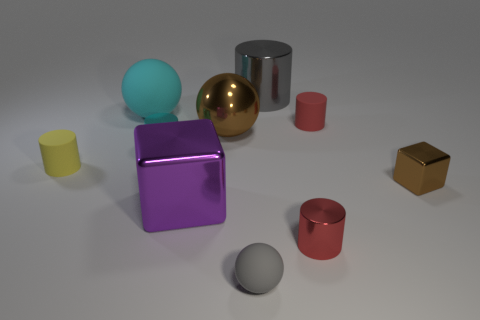Does the tiny red thing behind the big block have the same material as the big brown object?
Provide a succinct answer. No. What is the shape of the brown metal thing that is behind the brown metallic object on the right side of the shiny cylinder that is behind the large rubber thing?
Offer a very short reply. Sphere. Is there a yellow matte block that has the same size as the cyan rubber object?
Offer a terse response. No. How big is the purple metallic thing?
Provide a short and direct response. Large. What number of yellow objects have the same size as the cyan metal thing?
Your answer should be compact. 1. Is the number of big metal blocks that are behind the large purple cube less than the number of tiny matte cylinders to the right of the large metallic cylinder?
Make the answer very short. Yes. There is a brown shiny object that is on the right side of the tiny red cylinder that is in front of the tiny red thing behind the large metallic sphere; what is its size?
Offer a terse response. Small. There is a cylinder that is left of the small gray matte object and on the right side of the yellow cylinder; what is its size?
Keep it short and to the point. Small. What shape is the gray thing that is in front of the small thing that is left of the big cyan object?
Provide a succinct answer. Sphere. Are there any other things that have the same color as the big metallic cylinder?
Provide a short and direct response. Yes. 